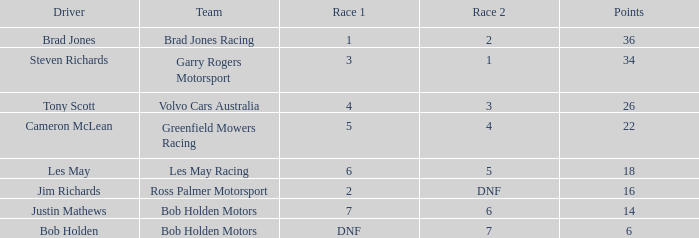In race 1, which team was awarded 4 points? Volvo Cars Australia. 